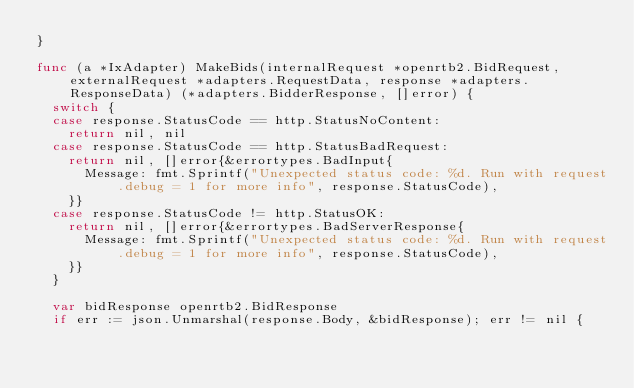Convert code to text. <code><loc_0><loc_0><loc_500><loc_500><_Go_>}

func (a *IxAdapter) MakeBids(internalRequest *openrtb2.BidRequest, externalRequest *adapters.RequestData, response *adapters.ResponseData) (*adapters.BidderResponse, []error) {
	switch {
	case response.StatusCode == http.StatusNoContent:
		return nil, nil
	case response.StatusCode == http.StatusBadRequest:
		return nil, []error{&errortypes.BadInput{
			Message: fmt.Sprintf("Unexpected status code: %d. Run with request.debug = 1 for more info", response.StatusCode),
		}}
	case response.StatusCode != http.StatusOK:
		return nil, []error{&errortypes.BadServerResponse{
			Message: fmt.Sprintf("Unexpected status code: %d. Run with request.debug = 1 for more info", response.StatusCode),
		}}
	}

	var bidResponse openrtb2.BidResponse
	if err := json.Unmarshal(response.Body, &bidResponse); err != nil {</code> 